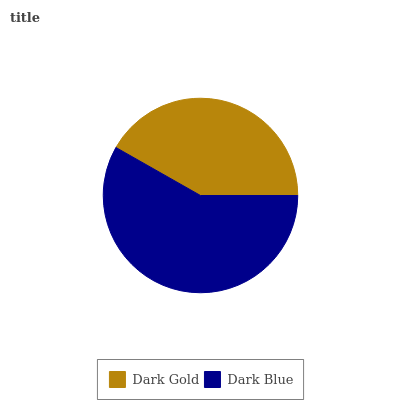Is Dark Gold the minimum?
Answer yes or no. Yes. Is Dark Blue the maximum?
Answer yes or no. Yes. Is Dark Blue the minimum?
Answer yes or no. No. Is Dark Blue greater than Dark Gold?
Answer yes or no. Yes. Is Dark Gold less than Dark Blue?
Answer yes or no. Yes. Is Dark Gold greater than Dark Blue?
Answer yes or no. No. Is Dark Blue less than Dark Gold?
Answer yes or no. No. Is Dark Blue the high median?
Answer yes or no. Yes. Is Dark Gold the low median?
Answer yes or no. Yes. Is Dark Gold the high median?
Answer yes or no. No. Is Dark Blue the low median?
Answer yes or no. No. 